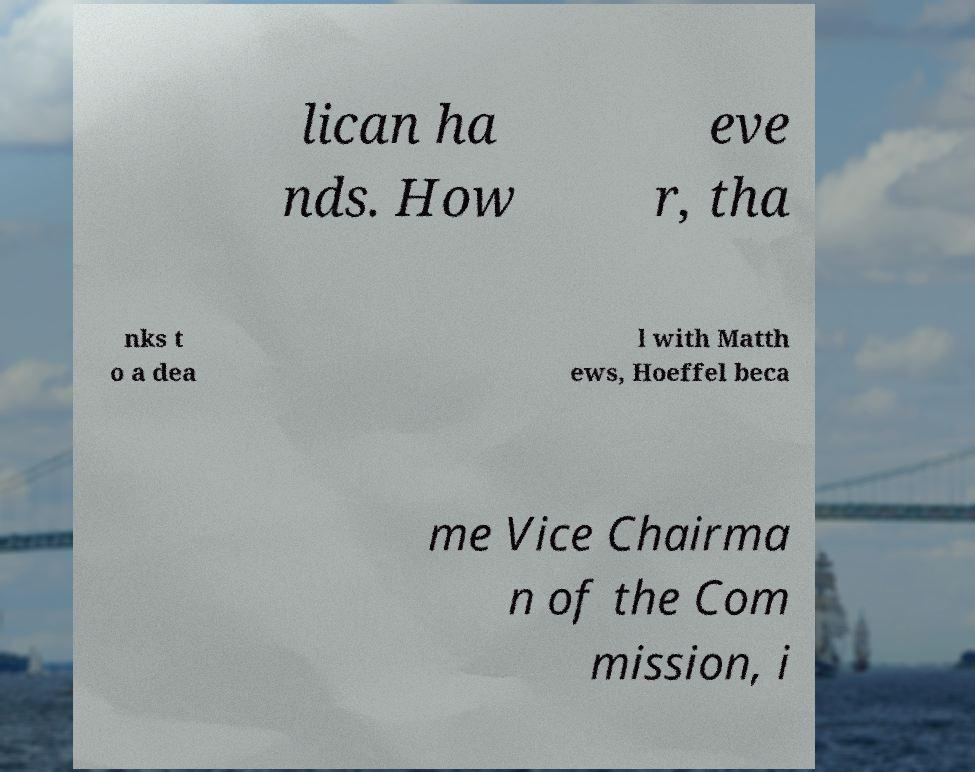What messages or text are displayed in this image? I need them in a readable, typed format. lican ha nds. How eve r, tha nks t o a dea l with Matth ews, Hoeffel beca me Vice Chairma n of the Com mission, i 